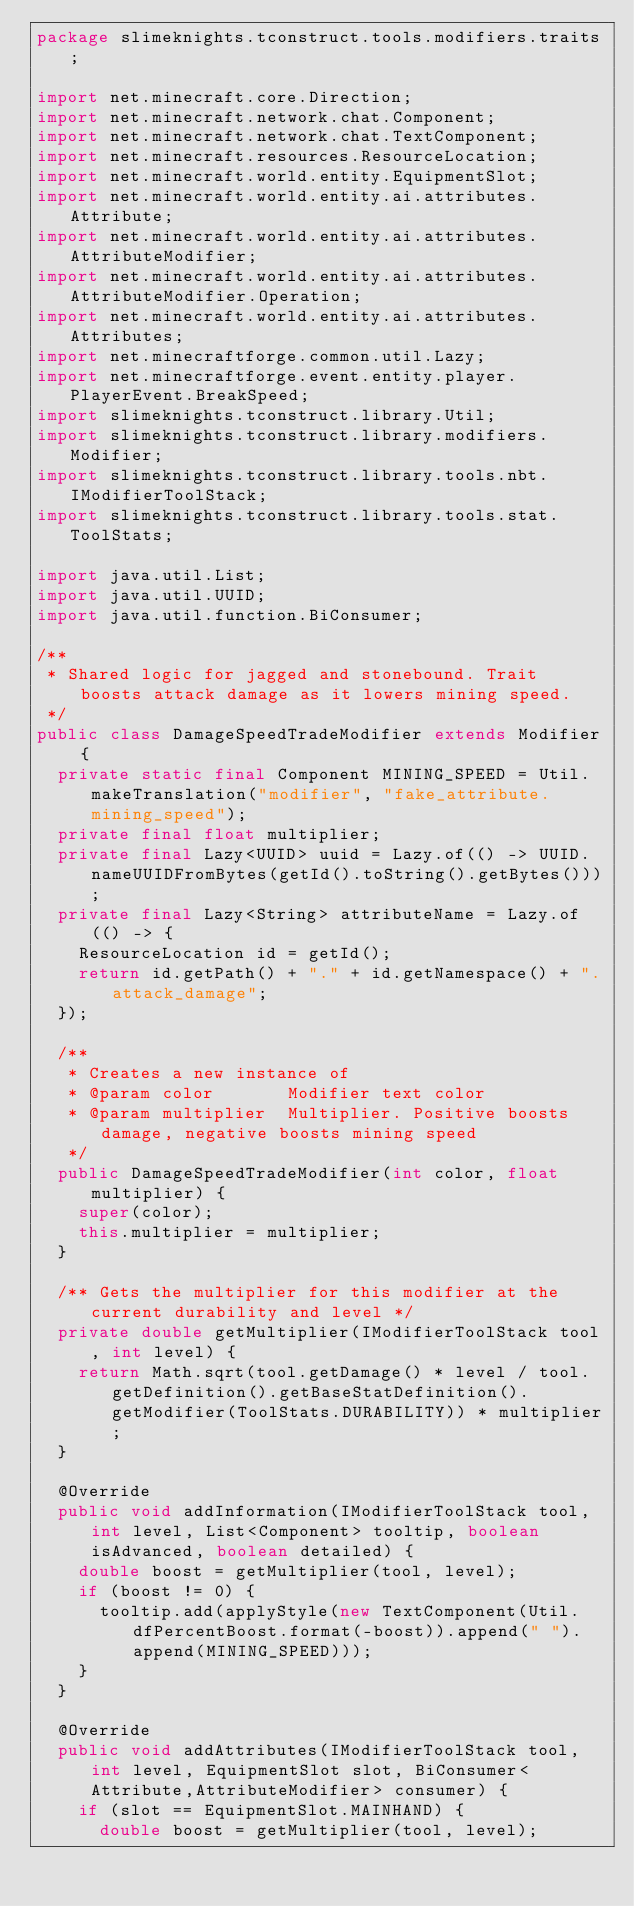Convert code to text. <code><loc_0><loc_0><loc_500><loc_500><_Java_>package slimeknights.tconstruct.tools.modifiers.traits;

import net.minecraft.core.Direction;
import net.minecraft.network.chat.Component;
import net.minecraft.network.chat.TextComponent;
import net.minecraft.resources.ResourceLocation;
import net.minecraft.world.entity.EquipmentSlot;
import net.minecraft.world.entity.ai.attributes.Attribute;
import net.minecraft.world.entity.ai.attributes.AttributeModifier;
import net.minecraft.world.entity.ai.attributes.AttributeModifier.Operation;
import net.minecraft.world.entity.ai.attributes.Attributes;
import net.minecraftforge.common.util.Lazy;
import net.minecraftforge.event.entity.player.PlayerEvent.BreakSpeed;
import slimeknights.tconstruct.library.Util;
import slimeknights.tconstruct.library.modifiers.Modifier;
import slimeknights.tconstruct.library.tools.nbt.IModifierToolStack;
import slimeknights.tconstruct.library.tools.stat.ToolStats;

import java.util.List;
import java.util.UUID;
import java.util.function.BiConsumer;

/**
 * Shared logic for jagged and stonebound. Trait boosts attack damage as it lowers mining speed.
 */
public class DamageSpeedTradeModifier extends Modifier {
  private static final Component MINING_SPEED = Util.makeTranslation("modifier", "fake_attribute.mining_speed");
  private final float multiplier;
  private final Lazy<UUID> uuid = Lazy.of(() -> UUID.nameUUIDFromBytes(getId().toString().getBytes()));
  private final Lazy<String> attributeName = Lazy.of(() -> {
    ResourceLocation id = getId();
    return id.getPath() + "." + id.getNamespace() + ".attack_damage";
  });

  /**
   * Creates a new instance of
   * @param color       Modifier text color
   * @param multiplier  Multiplier. Positive boosts damage, negative boosts mining speed
   */
  public DamageSpeedTradeModifier(int color, float multiplier) {
    super(color);
    this.multiplier = multiplier;
  }

  /** Gets the multiplier for this modifier at the current durability and level */
  private double getMultiplier(IModifierToolStack tool, int level) {
    return Math.sqrt(tool.getDamage() * level / tool.getDefinition().getBaseStatDefinition().getModifier(ToolStats.DURABILITY)) * multiplier;
  }

  @Override
  public void addInformation(IModifierToolStack tool, int level, List<Component> tooltip, boolean isAdvanced, boolean detailed) {
    double boost = getMultiplier(tool, level);
    if (boost != 0) {
      tooltip.add(applyStyle(new TextComponent(Util.dfPercentBoost.format(-boost)).append(" ").append(MINING_SPEED)));
    }
  }

  @Override
  public void addAttributes(IModifierToolStack tool, int level, EquipmentSlot slot, BiConsumer<Attribute,AttributeModifier> consumer) {
    if (slot == EquipmentSlot.MAINHAND) {
      double boost = getMultiplier(tool, level);</code> 